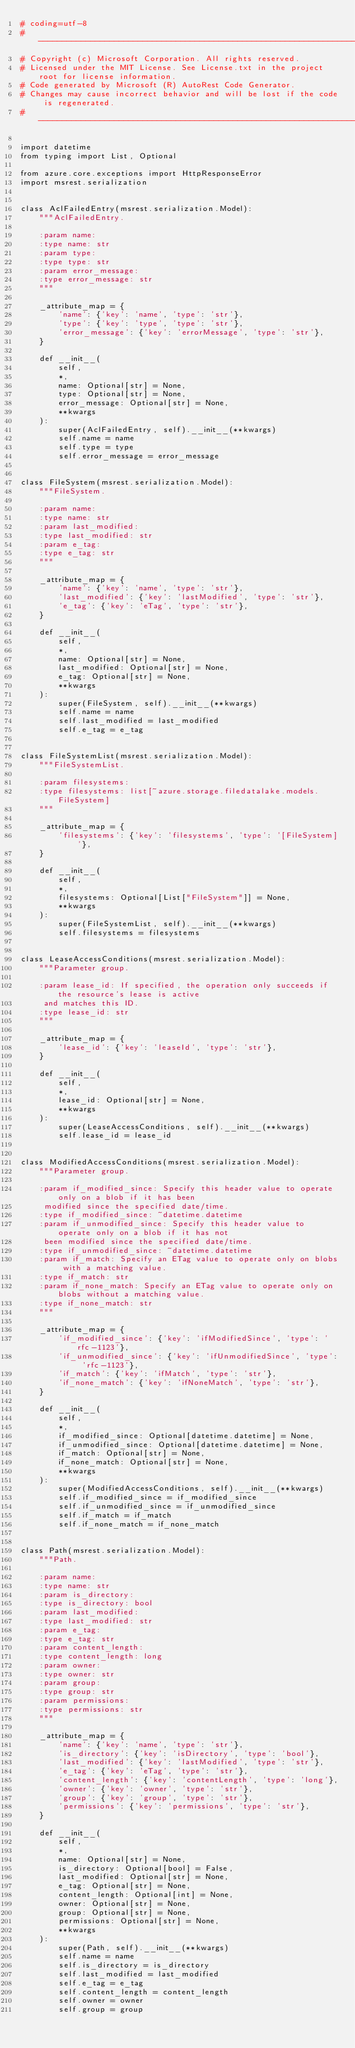Convert code to text. <code><loc_0><loc_0><loc_500><loc_500><_Python_># coding=utf-8
# --------------------------------------------------------------------------
# Copyright (c) Microsoft Corporation. All rights reserved.
# Licensed under the MIT License. See License.txt in the project root for license information.
# Code generated by Microsoft (R) AutoRest Code Generator.
# Changes may cause incorrect behavior and will be lost if the code is regenerated.
# --------------------------------------------------------------------------

import datetime
from typing import List, Optional

from azure.core.exceptions import HttpResponseError
import msrest.serialization


class AclFailedEntry(msrest.serialization.Model):
    """AclFailedEntry.

    :param name:
    :type name: str
    :param type:
    :type type: str
    :param error_message:
    :type error_message: str
    """

    _attribute_map = {
        'name': {'key': 'name', 'type': 'str'},
        'type': {'key': 'type', 'type': 'str'},
        'error_message': {'key': 'errorMessage', 'type': 'str'},
    }

    def __init__(
        self,
        *,
        name: Optional[str] = None,
        type: Optional[str] = None,
        error_message: Optional[str] = None,
        **kwargs
    ):
        super(AclFailedEntry, self).__init__(**kwargs)
        self.name = name
        self.type = type
        self.error_message = error_message


class FileSystem(msrest.serialization.Model):
    """FileSystem.

    :param name:
    :type name: str
    :param last_modified:
    :type last_modified: str
    :param e_tag:
    :type e_tag: str
    """

    _attribute_map = {
        'name': {'key': 'name', 'type': 'str'},
        'last_modified': {'key': 'lastModified', 'type': 'str'},
        'e_tag': {'key': 'eTag', 'type': 'str'},
    }

    def __init__(
        self,
        *,
        name: Optional[str] = None,
        last_modified: Optional[str] = None,
        e_tag: Optional[str] = None,
        **kwargs
    ):
        super(FileSystem, self).__init__(**kwargs)
        self.name = name
        self.last_modified = last_modified
        self.e_tag = e_tag


class FileSystemList(msrest.serialization.Model):
    """FileSystemList.

    :param filesystems:
    :type filesystems: list[~azure.storage.filedatalake.models.FileSystem]
    """

    _attribute_map = {
        'filesystems': {'key': 'filesystems', 'type': '[FileSystem]'},
    }

    def __init__(
        self,
        *,
        filesystems: Optional[List["FileSystem"]] = None,
        **kwargs
    ):
        super(FileSystemList, self).__init__(**kwargs)
        self.filesystems = filesystems


class LeaseAccessConditions(msrest.serialization.Model):
    """Parameter group.

    :param lease_id: If specified, the operation only succeeds if the resource's lease is active
     and matches this ID.
    :type lease_id: str
    """

    _attribute_map = {
        'lease_id': {'key': 'leaseId', 'type': 'str'},
    }

    def __init__(
        self,
        *,
        lease_id: Optional[str] = None,
        **kwargs
    ):
        super(LeaseAccessConditions, self).__init__(**kwargs)
        self.lease_id = lease_id


class ModifiedAccessConditions(msrest.serialization.Model):
    """Parameter group.

    :param if_modified_since: Specify this header value to operate only on a blob if it has been
     modified since the specified date/time.
    :type if_modified_since: ~datetime.datetime
    :param if_unmodified_since: Specify this header value to operate only on a blob if it has not
     been modified since the specified date/time.
    :type if_unmodified_since: ~datetime.datetime
    :param if_match: Specify an ETag value to operate only on blobs with a matching value.
    :type if_match: str
    :param if_none_match: Specify an ETag value to operate only on blobs without a matching value.
    :type if_none_match: str
    """

    _attribute_map = {
        'if_modified_since': {'key': 'ifModifiedSince', 'type': 'rfc-1123'},
        'if_unmodified_since': {'key': 'ifUnmodifiedSince', 'type': 'rfc-1123'},
        'if_match': {'key': 'ifMatch', 'type': 'str'},
        'if_none_match': {'key': 'ifNoneMatch', 'type': 'str'},
    }

    def __init__(
        self,
        *,
        if_modified_since: Optional[datetime.datetime] = None,
        if_unmodified_since: Optional[datetime.datetime] = None,
        if_match: Optional[str] = None,
        if_none_match: Optional[str] = None,
        **kwargs
    ):
        super(ModifiedAccessConditions, self).__init__(**kwargs)
        self.if_modified_since = if_modified_since
        self.if_unmodified_since = if_unmodified_since
        self.if_match = if_match
        self.if_none_match = if_none_match


class Path(msrest.serialization.Model):
    """Path.

    :param name:
    :type name: str
    :param is_directory:
    :type is_directory: bool
    :param last_modified:
    :type last_modified: str
    :param e_tag:
    :type e_tag: str
    :param content_length:
    :type content_length: long
    :param owner:
    :type owner: str
    :param group:
    :type group: str
    :param permissions:
    :type permissions: str
    """

    _attribute_map = {
        'name': {'key': 'name', 'type': 'str'},
        'is_directory': {'key': 'isDirectory', 'type': 'bool'},
        'last_modified': {'key': 'lastModified', 'type': 'str'},
        'e_tag': {'key': 'eTag', 'type': 'str'},
        'content_length': {'key': 'contentLength', 'type': 'long'},
        'owner': {'key': 'owner', 'type': 'str'},
        'group': {'key': 'group', 'type': 'str'},
        'permissions': {'key': 'permissions', 'type': 'str'},
    }

    def __init__(
        self,
        *,
        name: Optional[str] = None,
        is_directory: Optional[bool] = False,
        last_modified: Optional[str] = None,
        e_tag: Optional[str] = None,
        content_length: Optional[int] = None,
        owner: Optional[str] = None,
        group: Optional[str] = None,
        permissions: Optional[str] = None,
        **kwargs
    ):
        super(Path, self).__init__(**kwargs)
        self.name = name
        self.is_directory = is_directory
        self.last_modified = last_modified
        self.e_tag = e_tag
        self.content_length = content_length
        self.owner = owner
        self.group = group</code> 